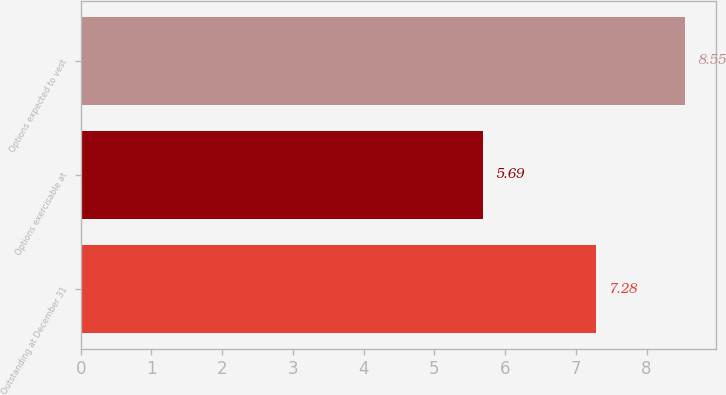Convert chart to OTSL. <chart><loc_0><loc_0><loc_500><loc_500><bar_chart><fcel>Outstanding at December 31<fcel>Options exercisable at<fcel>Options expected to vest<nl><fcel>7.28<fcel>5.69<fcel>8.55<nl></chart> 